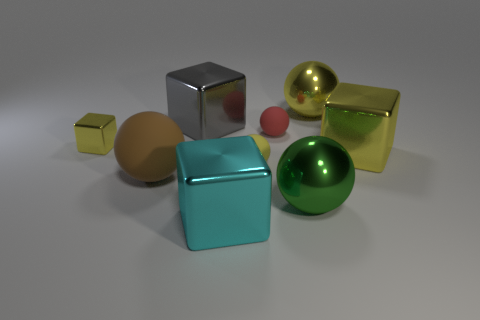What time of day or lighting setup could this image represent? The lighting in the image suggests an indoor setup with soft, diffused lights, possibly LED lamps. The lack of harsh shadows indicates that the light sources are well positioned, providing even illumination that one would use in a product photography studio or a digital rendering simulation to highlight the objects' details. Does this lighting affect the visibility of textures on the objects? Yes, the diffuse lighting accentuates the textures by softly highlighting the differences in reflectivity and surface roughness. It allows us to see the subtle reflections on the metallic objects and the smoother, matte finish on the non-metallic ones, such as the yellow cylinder. 